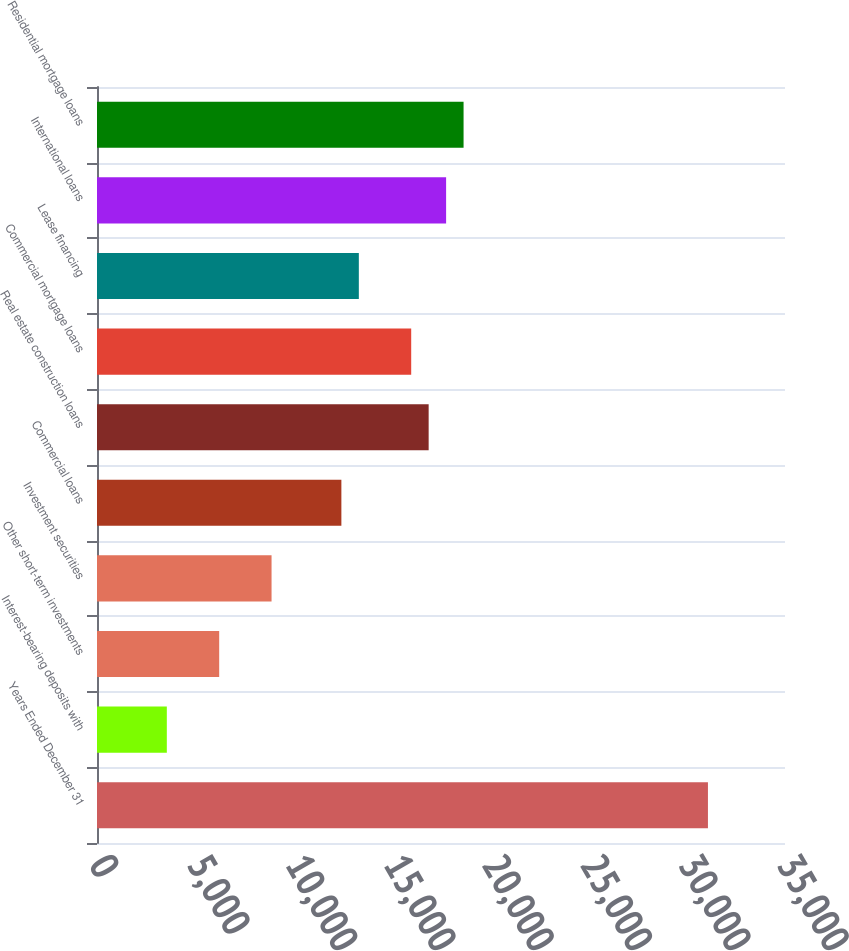<chart> <loc_0><loc_0><loc_500><loc_500><bar_chart><fcel>Years Ended December 31<fcel>Interest-bearing deposits with<fcel>Other short-term investments<fcel>Investment securities<fcel>Commercial loans<fcel>Real estate construction loans<fcel>Commercial mortgage loans<fcel>Lease financing<fcel>International loans<fcel>Residential mortgage loans<nl><fcel>31080<fcel>3552.05<fcel>6216.05<fcel>8880.05<fcel>12432<fcel>16872<fcel>15984<fcel>13320<fcel>17760<fcel>18648<nl></chart> 